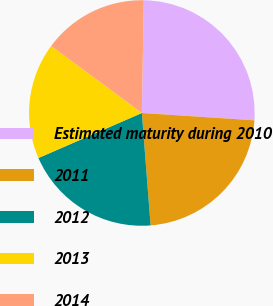<chart> <loc_0><loc_0><loc_500><loc_500><pie_chart><fcel>Estimated maturity during 2010<fcel>2011<fcel>2012<fcel>2013<fcel>2014<nl><fcel>25.76%<fcel>22.73%<fcel>19.7%<fcel>16.67%<fcel>15.15%<nl></chart> 